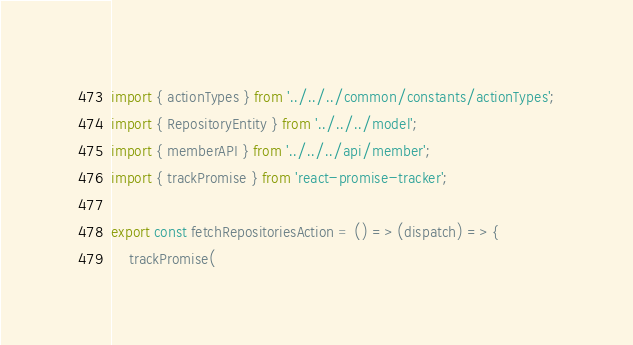Convert code to text. <code><loc_0><loc_0><loc_500><loc_500><_TypeScript_>import { actionTypes } from '../../../common/constants/actionTypes';
import { RepositoryEntity } from '../../../model';
import { memberAPI } from '../../../api/member';
import { trackPromise } from 'react-promise-tracker';

export const fetchRepositoriesAction = () => (dispatch) => {
    trackPromise(</code> 